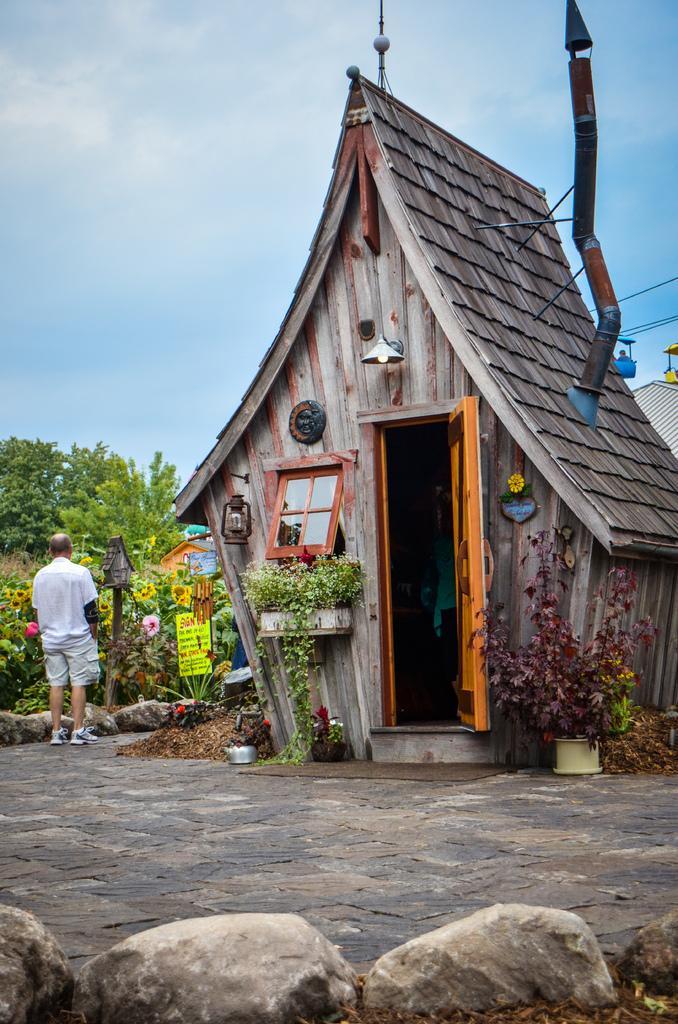Please provide a concise description of this image. In this image I can see house and I can see a mirror attached to the wall of the house and I can see flower pots and crepes and person , flowers ,trees visible in front of house and I can see the sky, cable wires at the top, at bottom I can see stones. 